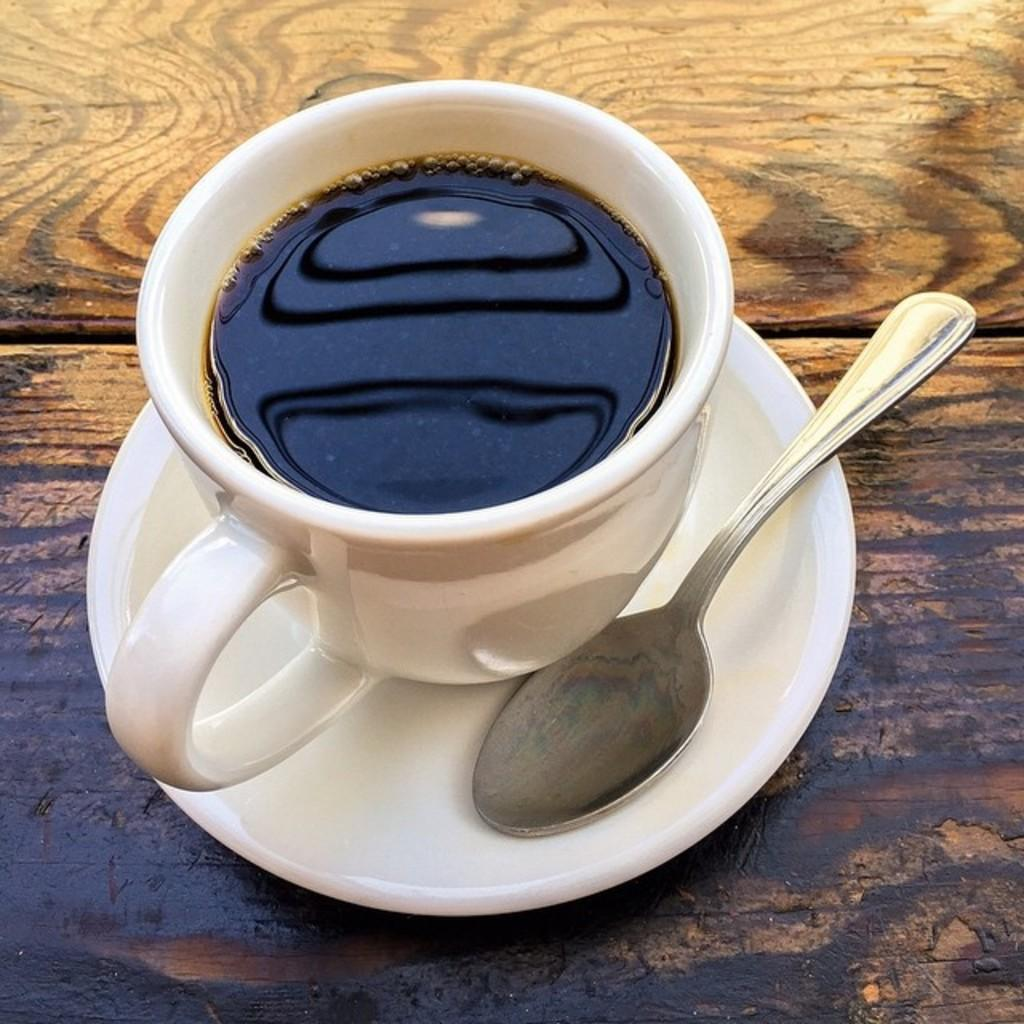What is in the cup that is visible in the image? There is a drink in the cup in the image. What is placed under the cup in the image? There is a saucer in the image. What utensil is placed with the cup and saucer? There is a spoon in the image. What material is the table made of in the image? The table in the image is made of wood. What color is the wish in the image? There is no wish present in the image, as wishes are not visible objects. 